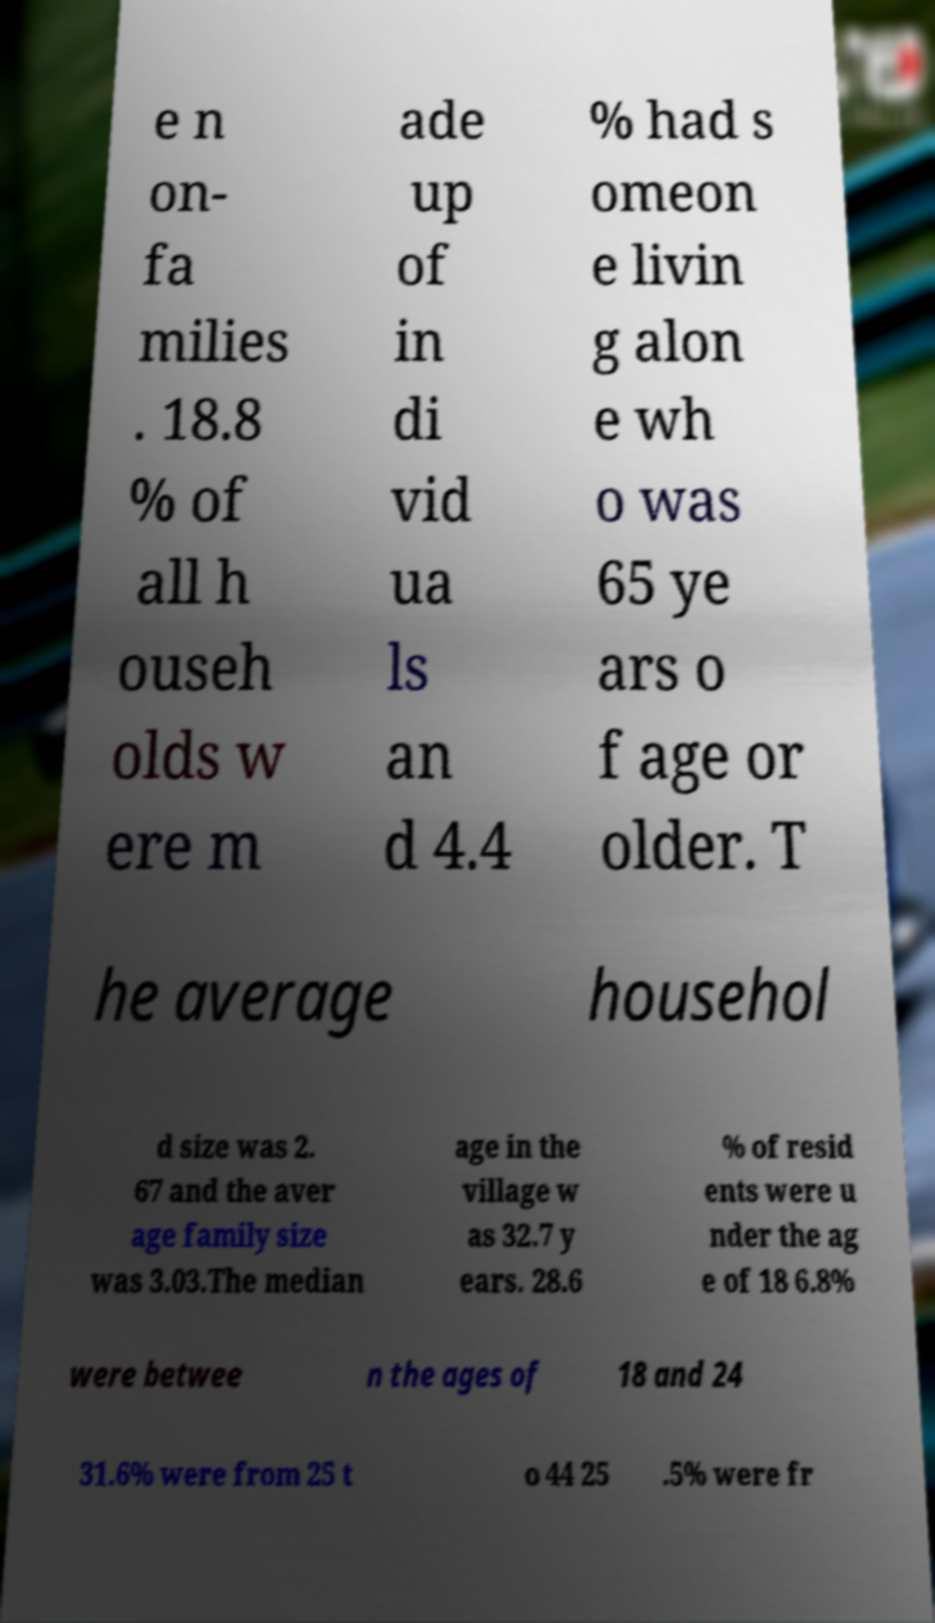For documentation purposes, I need the text within this image transcribed. Could you provide that? e n on- fa milies . 18.8 % of all h ouseh olds w ere m ade up of in di vid ua ls an d 4.4 % had s omeon e livin g alon e wh o was 65 ye ars o f age or older. T he average househol d size was 2. 67 and the aver age family size was 3.03.The median age in the village w as 32.7 y ears. 28.6 % of resid ents were u nder the ag e of 18 6.8% were betwee n the ages of 18 and 24 31.6% were from 25 t o 44 25 .5% were fr 